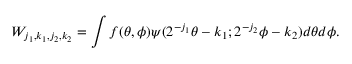<formula> <loc_0><loc_0><loc_500><loc_500>W _ { j _ { 1 } , k _ { 1 } , j _ { 2 } , k _ { 2 } } = \int f ( \theta , \phi ) \psi ( 2 ^ { - j _ { 1 } } \theta - k _ { 1 } ; 2 ^ { - j _ { 2 } } \phi - k _ { 2 } ) d \theta d \phi .</formula> 